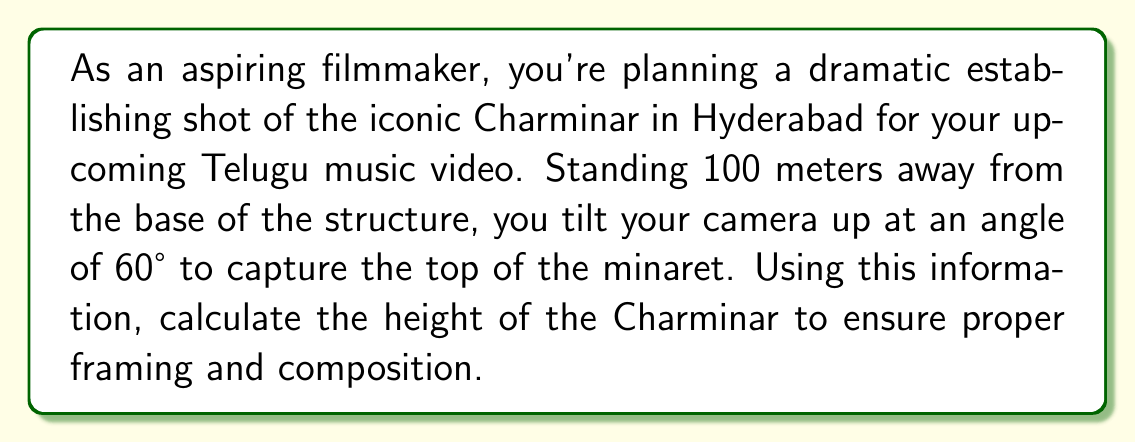Show me your answer to this math problem. Let's approach this step-by-step using trigonometry:

1) In this scenario, we have a right-angled triangle. The base of the triangle is the distance from where you're standing to the Charminar (100 meters), and the height of the Charminar is what we need to find.

2) The angle of elevation (the tilt of your camera) is 60°.

3) In a right-angled triangle, tangent of an angle is the ratio of the opposite side to the adjacent side.

   $$\tan \theta = \frac{\text{opposite}}{\text{adjacent}}$$

4) In our case:
   - θ (theta) = 60°
   - adjacent = 100 meters
   - opposite = height of Charminar (let's call it h)

5) We can write the equation:

   $$\tan 60° = \frac{h}{100}$$

6) We know that $\tan 60° = \sqrt{3}$

7) Substituting this:

   $$\sqrt{3} = \frac{h}{100}$$

8) To solve for h, multiply both sides by 100:

   $$100\sqrt{3} = h$$

9) Calculate the value:
   
   $$h \approx 173.2 \text{ meters}$$

[asy]
import geometry;

size(200);
pair A=(0,0), B=(100,0), C=(100,173.2);
draw(A--B--C--A);
draw(B--C,dashed);
label("100 m",B--A,S);
label("173.2 m",C--B,E);
label("60°",A,NE);
dot("A",A,SW);
dot("B",B,SE);
dot("C",C,NE);
[/asy]
Answer: $173.2 \text{ meters}$ 